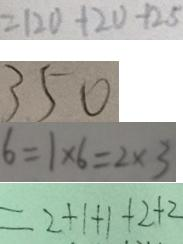Convert formula to latex. <formula><loc_0><loc_0><loc_500><loc_500>= 1 2 0 + 2 0 - 1 2 5 
 3 5 0 
 6 = 1 \times 6 = 2 \times 3 
 = 2 + 1 + 1 + 2 + 2</formula> 